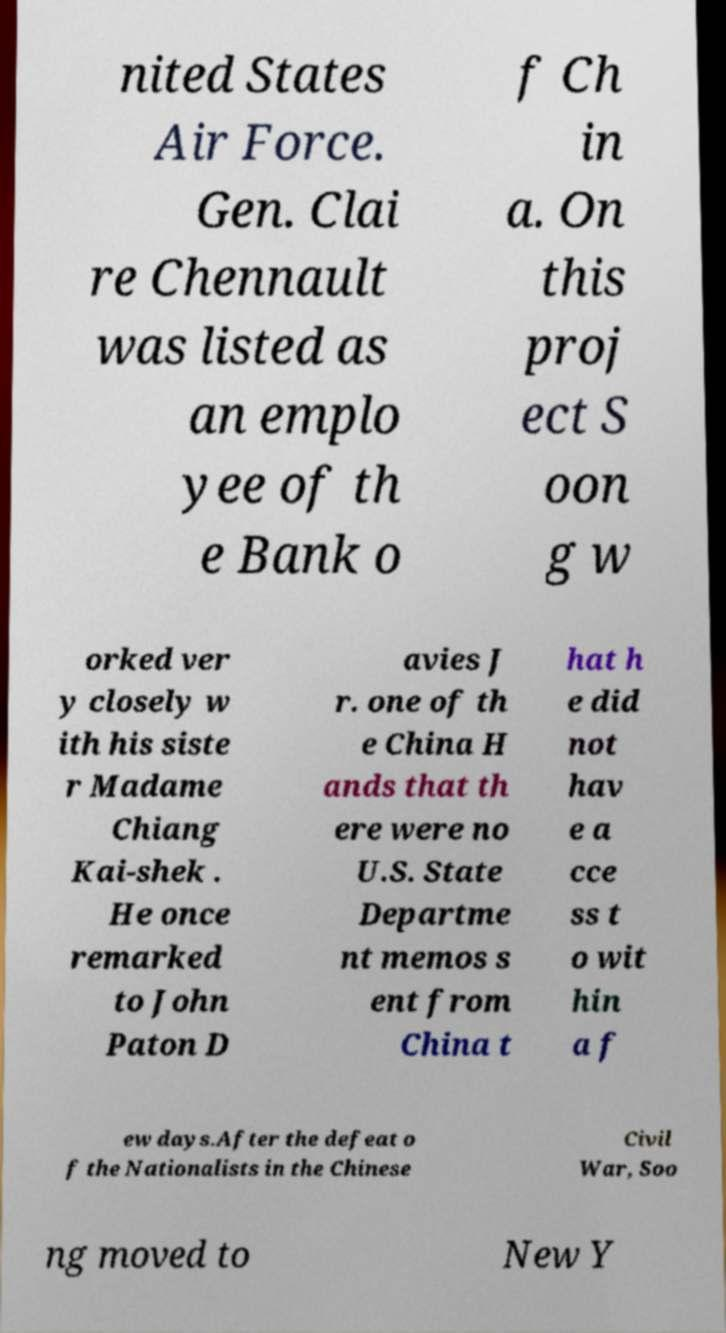There's text embedded in this image that I need extracted. Can you transcribe it verbatim? nited States Air Force. Gen. Clai re Chennault was listed as an emplo yee of th e Bank o f Ch in a. On this proj ect S oon g w orked ver y closely w ith his siste r Madame Chiang Kai-shek . He once remarked to John Paton D avies J r. one of th e China H ands that th ere were no U.S. State Departme nt memos s ent from China t hat h e did not hav e a cce ss t o wit hin a f ew days.After the defeat o f the Nationalists in the Chinese Civil War, Soo ng moved to New Y 